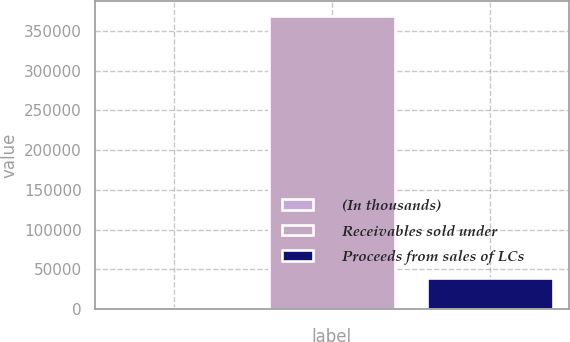<chart> <loc_0><loc_0><loc_500><loc_500><bar_chart><fcel>(In thousands)<fcel>Receivables sold under<fcel>Proceeds from sales of LCs<nl><fcel>2012<fcel>368894<fcel>38700.2<nl></chart> 